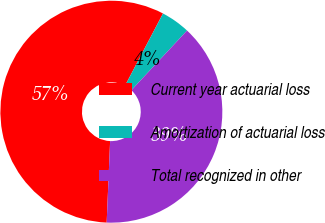<chart> <loc_0><loc_0><loc_500><loc_500><pie_chart><fcel>Current year actuarial loss<fcel>Amortization of actuarial loss<fcel>Total recognized in other<nl><fcel>57.03%<fcel>4.24%<fcel>38.73%<nl></chart> 